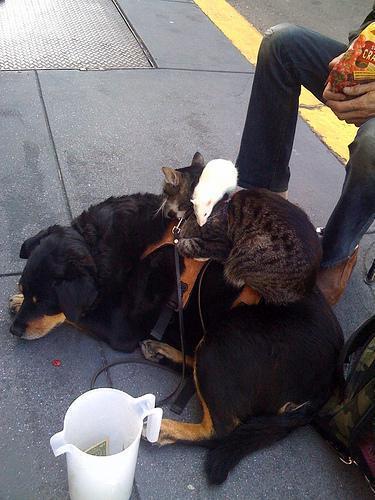How many birds do you see?
Give a very brief answer. 0. 